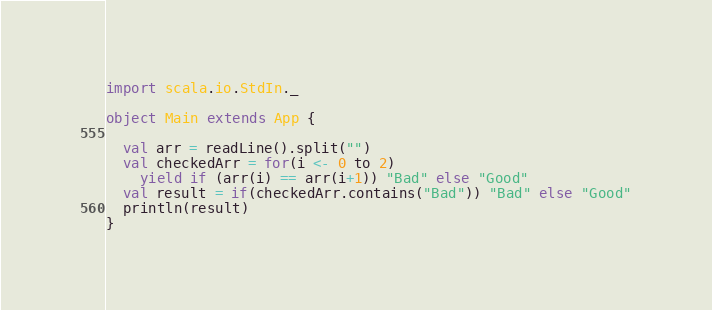<code> <loc_0><loc_0><loc_500><loc_500><_Scala_>import scala.io.StdIn._

object Main extends App {

  val arr = readLine().split("")
  val checkedArr = for(i <- 0 to 2)
    yield if (arr(i) == arr(i+1)) "Bad" else "Good"
  val result = if(checkedArr.contains("Bad")) "Bad" else "Good"
  println(result)
}
</code> 